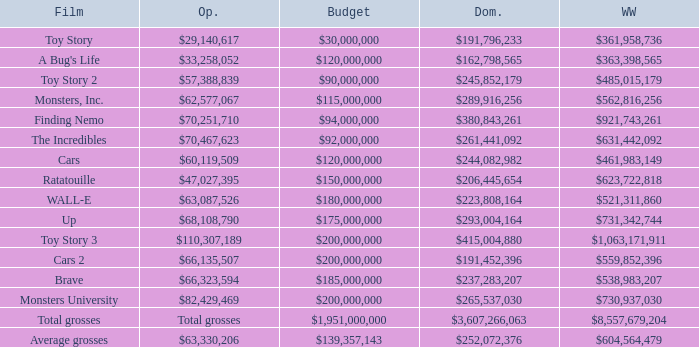WHAT IS THE BUDGET WHEN THE WORLDWIDE BOX OFFICE IS $363,398,565? $120,000,000. Parse the table in full. {'header': ['Film', 'Op.', 'Budget', 'Dom.', 'WW'], 'rows': [['Toy Story', '$29,140,617', '$30,000,000', '$191,796,233', '$361,958,736'], ["A Bug's Life", '$33,258,052', '$120,000,000', '$162,798,565', '$363,398,565'], ['Toy Story 2', '$57,388,839', '$90,000,000', '$245,852,179', '$485,015,179'], ['Monsters, Inc.', '$62,577,067', '$115,000,000', '$289,916,256', '$562,816,256'], ['Finding Nemo', '$70,251,710', '$94,000,000', '$380,843,261', '$921,743,261'], ['The Incredibles', '$70,467,623', '$92,000,000', '$261,441,092', '$631,442,092'], ['Cars', '$60,119,509', '$120,000,000', '$244,082,982', '$461,983,149'], ['Ratatouille', '$47,027,395', '$150,000,000', '$206,445,654', '$623,722,818'], ['WALL-E', '$63,087,526', '$180,000,000', '$223,808,164', '$521,311,860'], ['Up', '$68,108,790', '$175,000,000', '$293,004,164', '$731,342,744'], ['Toy Story 3', '$110,307,189', '$200,000,000', '$415,004,880', '$1,063,171,911'], ['Cars 2', '$66,135,507', '$200,000,000', '$191,452,396', '$559,852,396'], ['Brave', '$66,323,594', '$185,000,000', '$237,283,207', '$538,983,207'], ['Monsters University', '$82,429,469', '$200,000,000', '$265,537,030', '$730,937,030'], ['Total grosses', 'Total grosses', '$1,951,000,000', '$3,607,266,063', '$8,557,679,204'], ['Average grosses', '$63,330,206', '$139,357,143', '$252,072,376', '$604,564,479']]} 